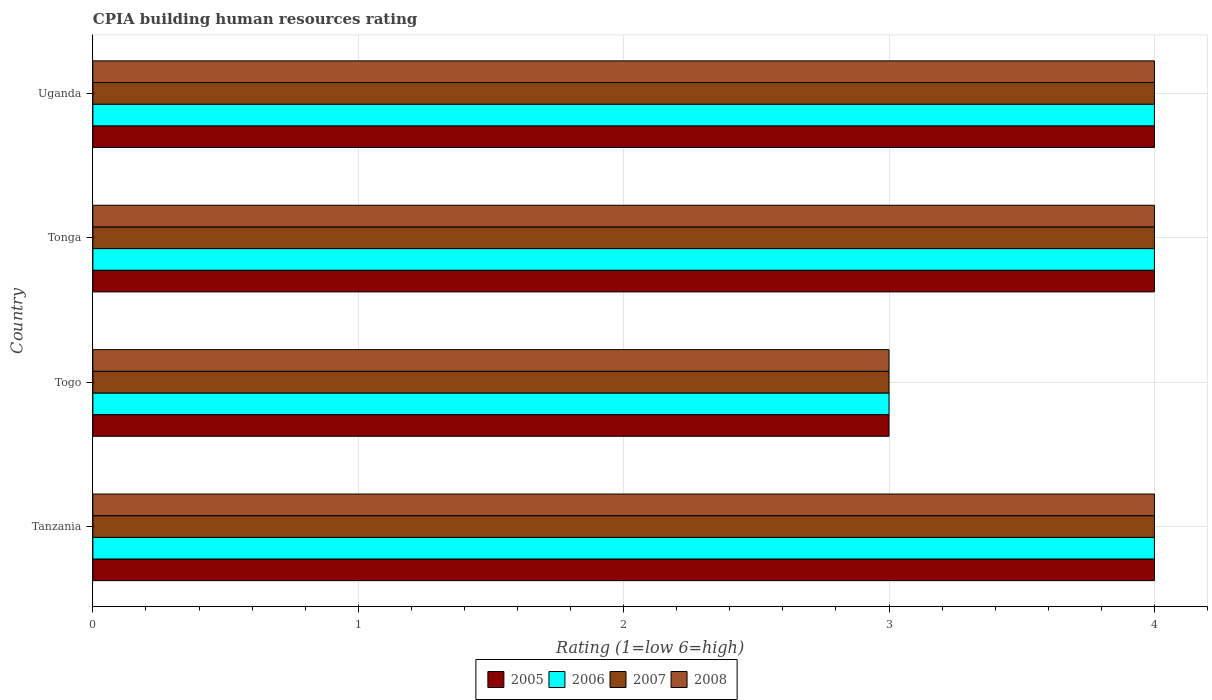How many groups of bars are there?
Your answer should be compact. 4. Are the number of bars on each tick of the Y-axis equal?
Offer a terse response. Yes. What is the label of the 3rd group of bars from the top?
Offer a very short reply. Togo. In which country was the CPIA rating in 2007 maximum?
Provide a succinct answer. Tanzania. In which country was the CPIA rating in 2008 minimum?
Make the answer very short. Togo. What is the difference between the CPIA rating in 2007 in Tanzania and that in Togo?
Keep it short and to the point. 1. What is the average CPIA rating in 2006 per country?
Keep it short and to the point. 3.75. In how many countries, is the CPIA rating in 2006 greater than 0.8 ?
Provide a short and direct response. 4. What is the difference between the highest and the lowest CPIA rating in 2005?
Give a very brief answer. 1. Is the sum of the CPIA rating in 2008 in Togo and Tonga greater than the maximum CPIA rating in 2007 across all countries?
Provide a short and direct response. Yes. Is it the case that in every country, the sum of the CPIA rating in 2005 and CPIA rating in 2006 is greater than the sum of CPIA rating in 2008 and CPIA rating in 2007?
Offer a very short reply. No. What does the 3rd bar from the top in Uganda represents?
Keep it short and to the point. 2006. Is it the case that in every country, the sum of the CPIA rating in 2006 and CPIA rating in 2005 is greater than the CPIA rating in 2008?
Offer a terse response. Yes. Are all the bars in the graph horizontal?
Make the answer very short. Yes. How many countries are there in the graph?
Offer a very short reply. 4. What is the difference between two consecutive major ticks on the X-axis?
Offer a terse response. 1. What is the title of the graph?
Give a very brief answer. CPIA building human resources rating. Does "1967" appear as one of the legend labels in the graph?
Keep it short and to the point. No. What is the Rating (1=low 6=high) in 2006 in Tanzania?
Offer a terse response. 4. What is the Rating (1=low 6=high) in 2007 in Tanzania?
Your answer should be very brief. 4. What is the Rating (1=low 6=high) of 2005 in Tonga?
Provide a short and direct response. 4. What is the Rating (1=low 6=high) in 2006 in Tonga?
Provide a succinct answer. 4. What is the Rating (1=low 6=high) in 2007 in Tonga?
Provide a succinct answer. 4. What is the Rating (1=low 6=high) in 2005 in Uganda?
Your answer should be very brief. 4. Across all countries, what is the maximum Rating (1=low 6=high) of 2005?
Make the answer very short. 4. Across all countries, what is the maximum Rating (1=low 6=high) of 2006?
Your response must be concise. 4. Across all countries, what is the maximum Rating (1=low 6=high) of 2008?
Your answer should be compact. 4. Across all countries, what is the minimum Rating (1=low 6=high) of 2005?
Your response must be concise. 3. Across all countries, what is the minimum Rating (1=low 6=high) of 2006?
Offer a terse response. 3. What is the total Rating (1=low 6=high) of 2005 in the graph?
Your response must be concise. 15. What is the total Rating (1=low 6=high) in 2007 in the graph?
Provide a short and direct response. 15. What is the difference between the Rating (1=low 6=high) in 2005 in Tanzania and that in Togo?
Provide a succinct answer. 1. What is the difference between the Rating (1=low 6=high) of 2006 in Tanzania and that in Togo?
Offer a terse response. 1. What is the difference between the Rating (1=low 6=high) of 2007 in Tanzania and that in Tonga?
Your response must be concise. 0. What is the difference between the Rating (1=low 6=high) in 2006 in Togo and that in Tonga?
Your response must be concise. -1. What is the difference between the Rating (1=low 6=high) of 2008 in Togo and that in Tonga?
Give a very brief answer. -1. What is the difference between the Rating (1=low 6=high) in 2007 in Togo and that in Uganda?
Keep it short and to the point. -1. What is the difference between the Rating (1=low 6=high) of 2006 in Tonga and that in Uganda?
Ensure brevity in your answer.  0. What is the difference between the Rating (1=low 6=high) of 2007 in Tonga and that in Uganda?
Provide a succinct answer. 0. What is the difference between the Rating (1=low 6=high) of 2005 in Tanzania and the Rating (1=low 6=high) of 2007 in Togo?
Give a very brief answer. 1. What is the difference between the Rating (1=low 6=high) of 2006 in Tanzania and the Rating (1=low 6=high) of 2007 in Togo?
Make the answer very short. 1. What is the difference between the Rating (1=low 6=high) of 2006 in Tanzania and the Rating (1=low 6=high) of 2008 in Togo?
Your answer should be compact. 1. What is the difference between the Rating (1=low 6=high) in 2005 in Tanzania and the Rating (1=low 6=high) in 2006 in Tonga?
Your answer should be very brief. 0. What is the difference between the Rating (1=low 6=high) of 2005 in Tanzania and the Rating (1=low 6=high) of 2007 in Tonga?
Provide a succinct answer. 0. What is the difference between the Rating (1=low 6=high) of 2006 in Tanzania and the Rating (1=low 6=high) of 2007 in Tonga?
Provide a short and direct response. 0. What is the difference between the Rating (1=low 6=high) of 2005 in Tanzania and the Rating (1=low 6=high) of 2006 in Uganda?
Give a very brief answer. 0. What is the difference between the Rating (1=low 6=high) in 2005 in Tanzania and the Rating (1=low 6=high) in 2007 in Uganda?
Provide a short and direct response. 0. What is the difference between the Rating (1=low 6=high) in 2005 in Tanzania and the Rating (1=low 6=high) in 2008 in Uganda?
Offer a very short reply. 0. What is the difference between the Rating (1=low 6=high) of 2006 in Tanzania and the Rating (1=low 6=high) of 2008 in Uganda?
Your answer should be very brief. 0. What is the difference between the Rating (1=low 6=high) of 2007 in Tanzania and the Rating (1=low 6=high) of 2008 in Uganda?
Your response must be concise. 0. What is the difference between the Rating (1=low 6=high) of 2005 in Togo and the Rating (1=low 6=high) of 2006 in Tonga?
Offer a terse response. -1. What is the difference between the Rating (1=low 6=high) in 2006 in Togo and the Rating (1=low 6=high) in 2008 in Tonga?
Provide a short and direct response. -1. What is the difference between the Rating (1=low 6=high) of 2005 in Togo and the Rating (1=low 6=high) of 2006 in Uganda?
Your response must be concise. -1. What is the difference between the Rating (1=low 6=high) of 2005 in Togo and the Rating (1=low 6=high) of 2008 in Uganda?
Your response must be concise. -1. What is the difference between the Rating (1=low 6=high) in 2006 in Togo and the Rating (1=low 6=high) in 2007 in Uganda?
Your answer should be very brief. -1. What is the difference between the Rating (1=low 6=high) of 2007 in Togo and the Rating (1=low 6=high) of 2008 in Uganda?
Provide a succinct answer. -1. What is the difference between the Rating (1=low 6=high) of 2006 in Tonga and the Rating (1=low 6=high) of 2007 in Uganda?
Provide a succinct answer. 0. What is the difference between the Rating (1=low 6=high) of 2006 in Tonga and the Rating (1=low 6=high) of 2008 in Uganda?
Keep it short and to the point. 0. What is the average Rating (1=low 6=high) of 2005 per country?
Give a very brief answer. 3.75. What is the average Rating (1=low 6=high) in 2006 per country?
Offer a very short reply. 3.75. What is the average Rating (1=low 6=high) of 2007 per country?
Your answer should be compact. 3.75. What is the average Rating (1=low 6=high) of 2008 per country?
Offer a very short reply. 3.75. What is the difference between the Rating (1=low 6=high) of 2005 and Rating (1=low 6=high) of 2007 in Tanzania?
Make the answer very short. 0. What is the difference between the Rating (1=low 6=high) in 2005 and Rating (1=low 6=high) in 2008 in Tanzania?
Your answer should be compact. 0. What is the difference between the Rating (1=low 6=high) in 2006 and Rating (1=low 6=high) in 2007 in Tanzania?
Your answer should be very brief. 0. What is the difference between the Rating (1=low 6=high) in 2007 and Rating (1=low 6=high) in 2008 in Tanzania?
Offer a terse response. 0. What is the difference between the Rating (1=low 6=high) in 2005 and Rating (1=low 6=high) in 2006 in Togo?
Make the answer very short. 0. What is the difference between the Rating (1=low 6=high) of 2005 and Rating (1=low 6=high) of 2007 in Togo?
Make the answer very short. 0. What is the difference between the Rating (1=low 6=high) in 2005 and Rating (1=low 6=high) in 2008 in Togo?
Make the answer very short. 0. What is the difference between the Rating (1=low 6=high) of 2006 and Rating (1=low 6=high) of 2007 in Togo?
Your answer should be very brief. 0. What is the difference between the Rating (1=low 6=high) in 2005 and Rating (1=low 6=high) in 2006 in Tonga?
Offer a very short reply. 0. What is the difference between the Rating (1=low 6=high) in 2006 and Rating (1=low 6=high) in 2007 in Tonga?
Make the answer very short. 0. What is the difference between the Rating (1=low 6=high) of 2006 and Rating (1=low 6=high) of 2008 in Tonga?
Provide a short and direct response. 0. What is the difference between the Rating (1=low 6=high) in 2006 and Rating (1=low 6=high) in 2007 in Uganda?
Provide a short and direct response. 0. What is the difference between the Rating (1=low 6=high) in 2006 and Rating (1=low 6=high) in 2008 in Uganda?
Provide a short and direct response. 0. What is the ratio of the Rating (1=low 6=high) in 2005 in Tanzania to that in Togo?
Provide a succinct answer. 1.33. What is the ratio of the Rating (1=low 6=high) in 2006 in Tanzania to that in Togo?
Provide a short and direct response. 1.33. What is the ratio of the Rating (1=low 6=high) in 2007 in Tanzania to that in Togo?
Your answer should be compact. 1.33. What is the ratio of the Rating (1=low 6=high) in 2007 in Tanzania to that in Tonga?
Keep it short and to the point. 1. What is the ratio of the Rating (1=low 6=high) in 2005 in Tanzania to that in Uganda?
Provide a succinct answer. 1. What is the ratio of the Rating (1=low 6=high) of 2005 in Togo to that in Tonga?
Your answer should be very brief. 0.75. What is the ratio of the Rating (1=low 6=high) of 2007 in Togo to that in Tonga?
Provide a succinct answer. 0.75. What is the ratio of the Rating (1=low 6=high) of 2006 in Togo to that in Uganda?
Provide a short and direct response. 0.75. What is the ratio of the Rating (1=low 6=high) in 2008 in Togo to that in Uganda?
Offer a terse response. 0.75. What is the ratio of the Rating (1=low 6=high) in 2005 in Tonga to that in Uganda?
Your answer should be compact. 1. What is the ratio of the Rating (1=low 6=high) of 2006 in Tonga to that in Uganda?
Offer a very short reply. 1. What is the ratio of the Rating (1=low 6=high) in 2007 in Tonga to that in Uganda?
Ensure brevity in your answer.  1. What is the ratio of the Rating (1=low 6=high) of 2008 in Tonga to that in Uganda?
Ensure brevity in your answer.  1. What is the difference between the highest and the second highest Rating (1=low 6=high) in 2005?
Offer a very short reply. 0. What is the difference between the highest and the second highest Rating (1=low 6=high) in 2006?
Your answer should be compact. 0. What is the difference between the highest and the second highest Rating (1=low 6=high) in 2007?
Make the answer very short. 0. 